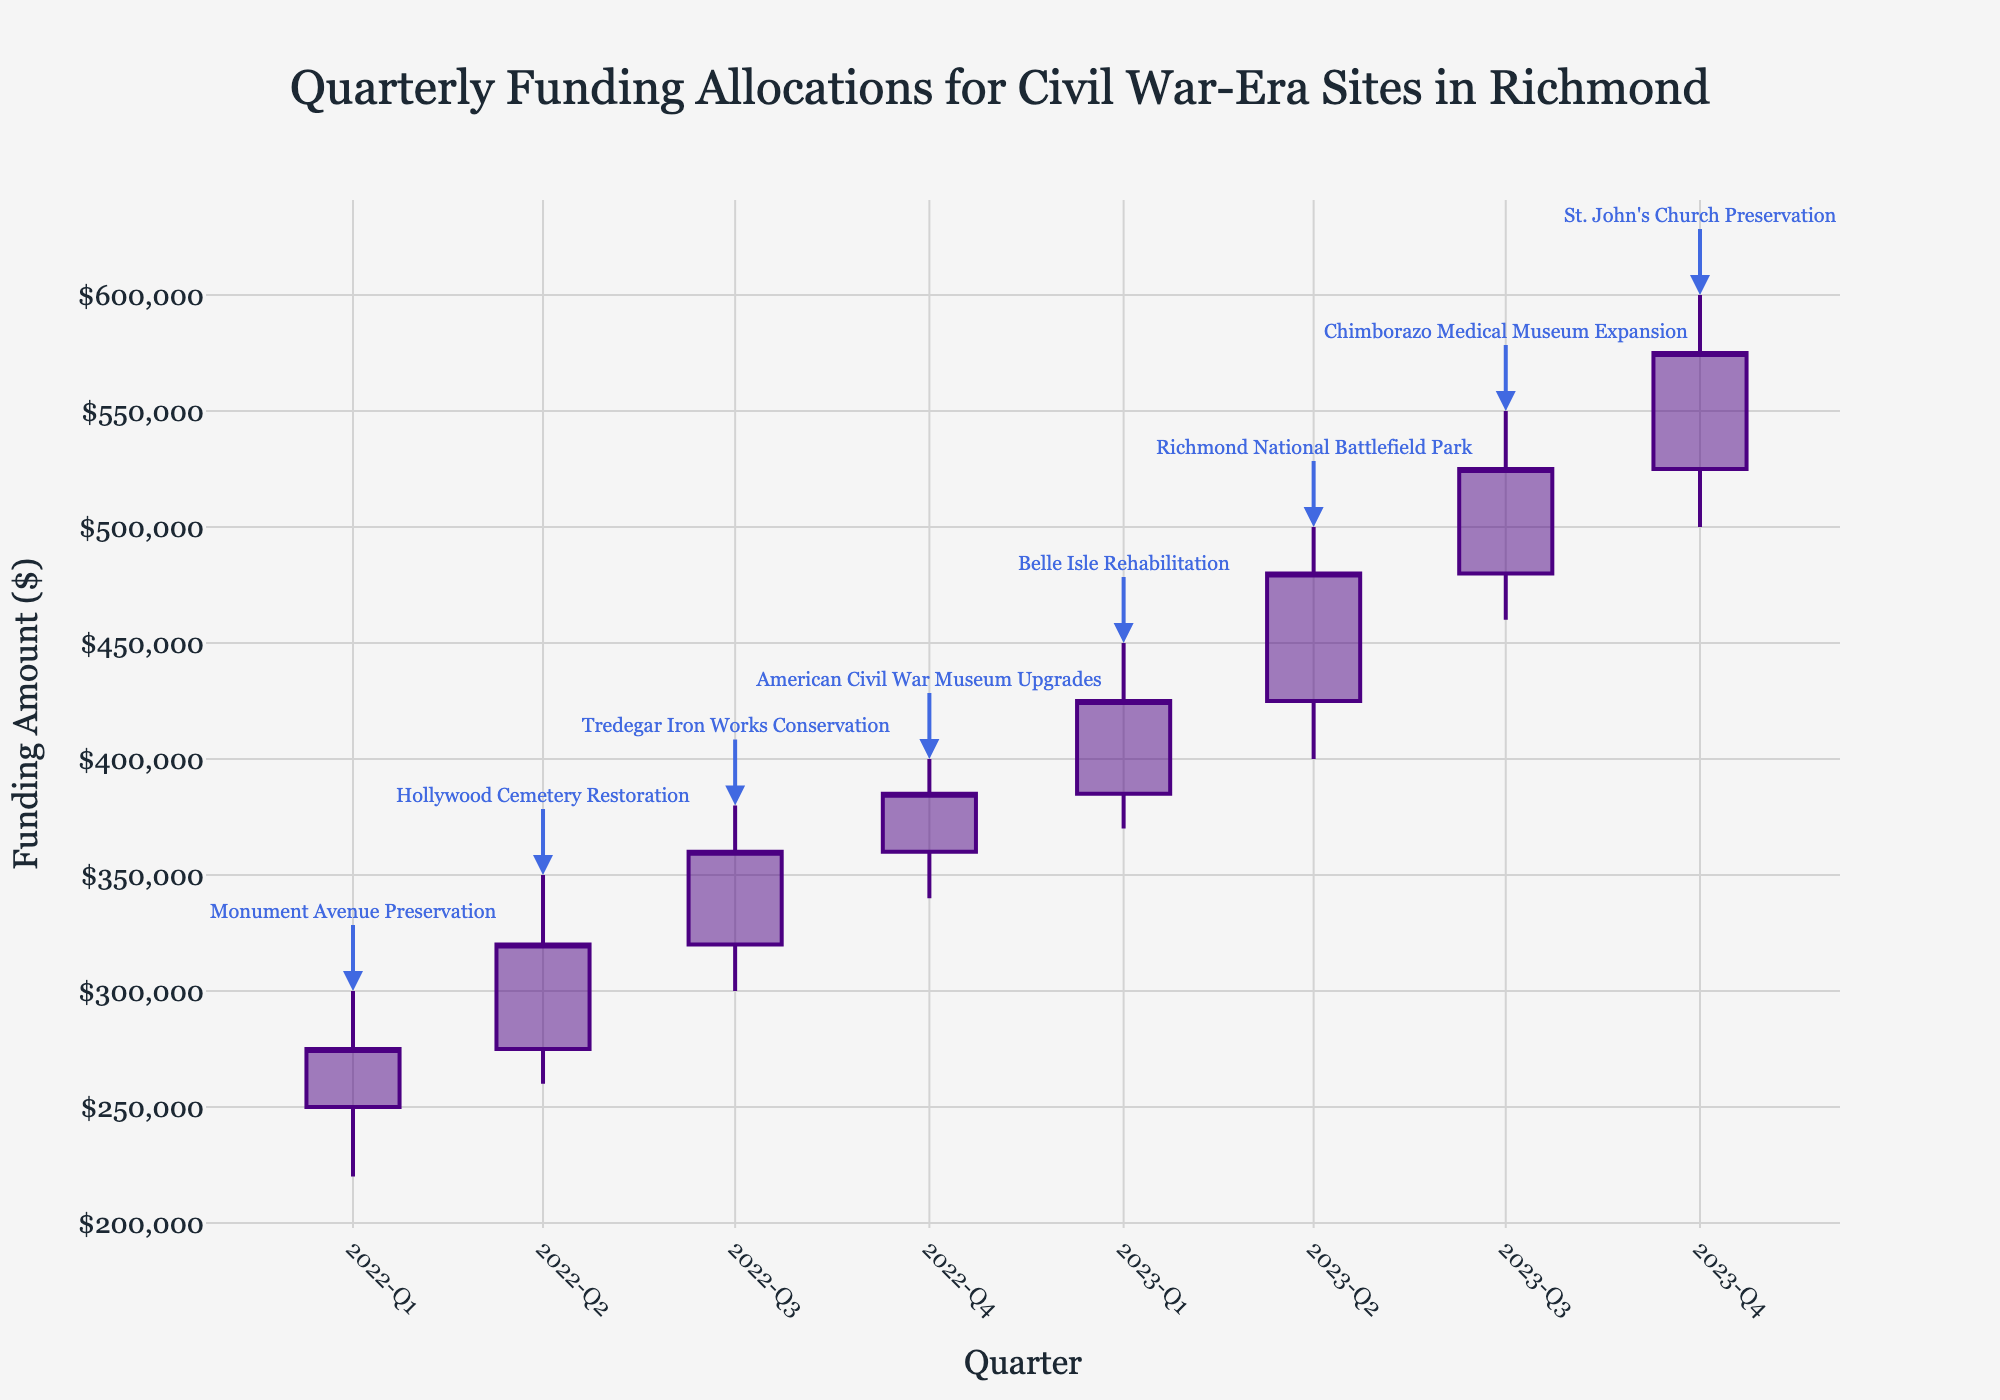What is the title of the chart? The title is located at the top of the figure and clearly explains the topic of the chart.
Answer: Quarterly Funding Allocations for Civil War-Era Sites in Richmond What is the highest funding amount recorded in the chart and in which quarter was it recorded? Look for the quarter with the highest 'High' value in the chart's data points. The shade of blue indicates these high points.
Answer: $600,000 in 2023-Q4 Which project received the lowest funding allocation within a single quarter? Look for the 'Low' value that is the smallest across all data points and identify the associated project from the annotations.
Answer: Monument Avenue Preservation in 2022-Q1 What is the trend in the funding from 2022-Q1 to 2023-Q4? Observe the OHLC chart to see how the 'Close' values progress from the beginning to the end. The trend should be a visual upward or downward progression or stability.
Answer: The trend is upward How much did the funding amount increase from 2022-Q1 to 2023-Q4? Look at the 'Close' values of 2022-Q1 and 2023-Q4. Subtract the 'Close' of 2022-Q1 from the 'Close' of 2023-Q4 to find the increase.
Answer: $300,000 What quarter saw the largest single increase in closing funding compared to the previous quarter? Calculate the difference between the 'Close' values of consecutive quarters and identify which one has the largest positive difference.
Answer: 2023-Q2 Which project achieved the highest closing funding amount and what was that amount? Examine the 'Close' values for each quarter to find the highest one and refer to the annotation to identify the project.
Answer: St. John's Church Preservation with $575,000 How many quarters show a decrease in funding from open to close within the same quarter? For each data point, check if the 'Close' is less than the 'Open'. Count how many such instances occur.
Answer: 0 quarters In which quarters did the Belle Isle Rehabilitation project receive funding? Check the annotations to find the quarter associated with the Belle Isle Rehabilitation project.
Answer: 2023-Q1 How does the funding for Richmond National Battlefield Park in 2023-Q2 compare to Hollywood Cemetery Restoration in 2022-Q2? Compare the 'Close' values of 2023-Q2 and 2022-Q2 as indicated by the annotations. Determine which one is higher and by how much.
Answer: Richmond National Battlefield Park's funding was $160,000 higher than Hollywood Cemetery Restoration 